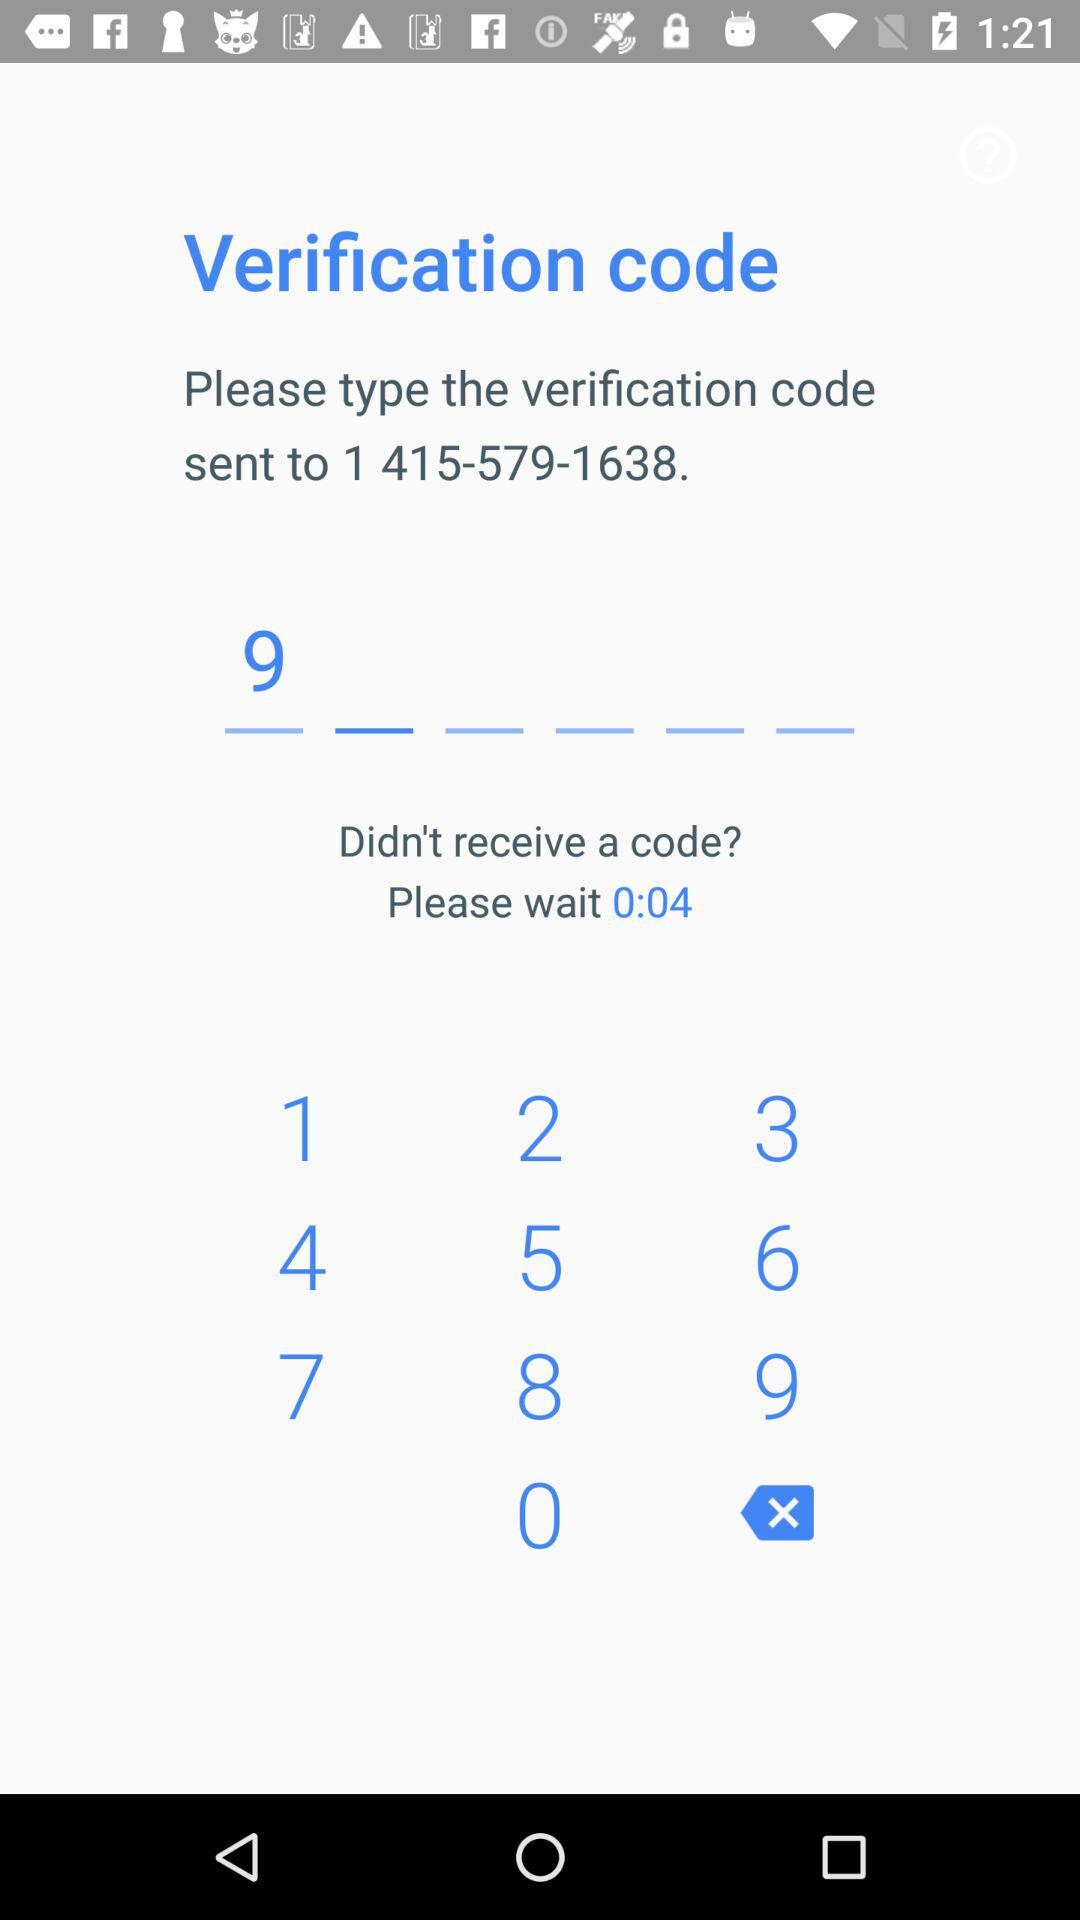What is the contact number for the verification code? The contact number is 1 415-579-1638. 